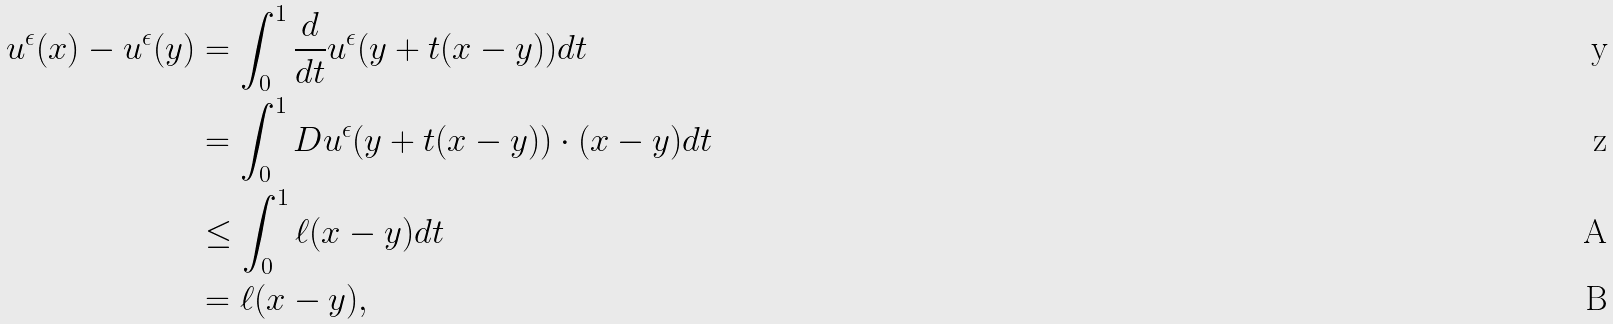<formula> <loc_0><loc_0><loc_500><loc_500>u ^ { \epsilon } ( x ) - u ^ { \epsilon } ( y ) & = \int ^ { 1 } _ { 0 } \frac { d } { d t } u ^ { \epsilon } ( y + t ( x - y ) ) d t \\ & = \int ^ { 1 } _ { 0 } D u ^ { \epsilon } ( y + t ( x - y ) ) \cdot ( x - y ) d t \\ & \leq \int ^ { 1 } _ { 0 } \ell ( x - y ) d t \\ & = \ell ( x - y ) ,</formula> 